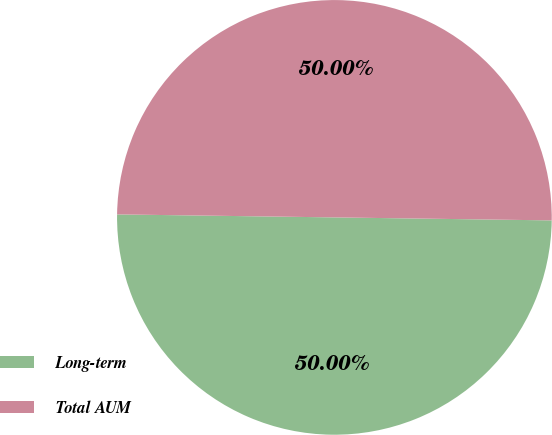Convert chart. <chart><loc_0><loc_0><loc_500><loc_500><pie_chart><fcel>Long-term<fcel>Total AUM<nl><fcel>50.0%<fcel>50.0%<nl></chart> 